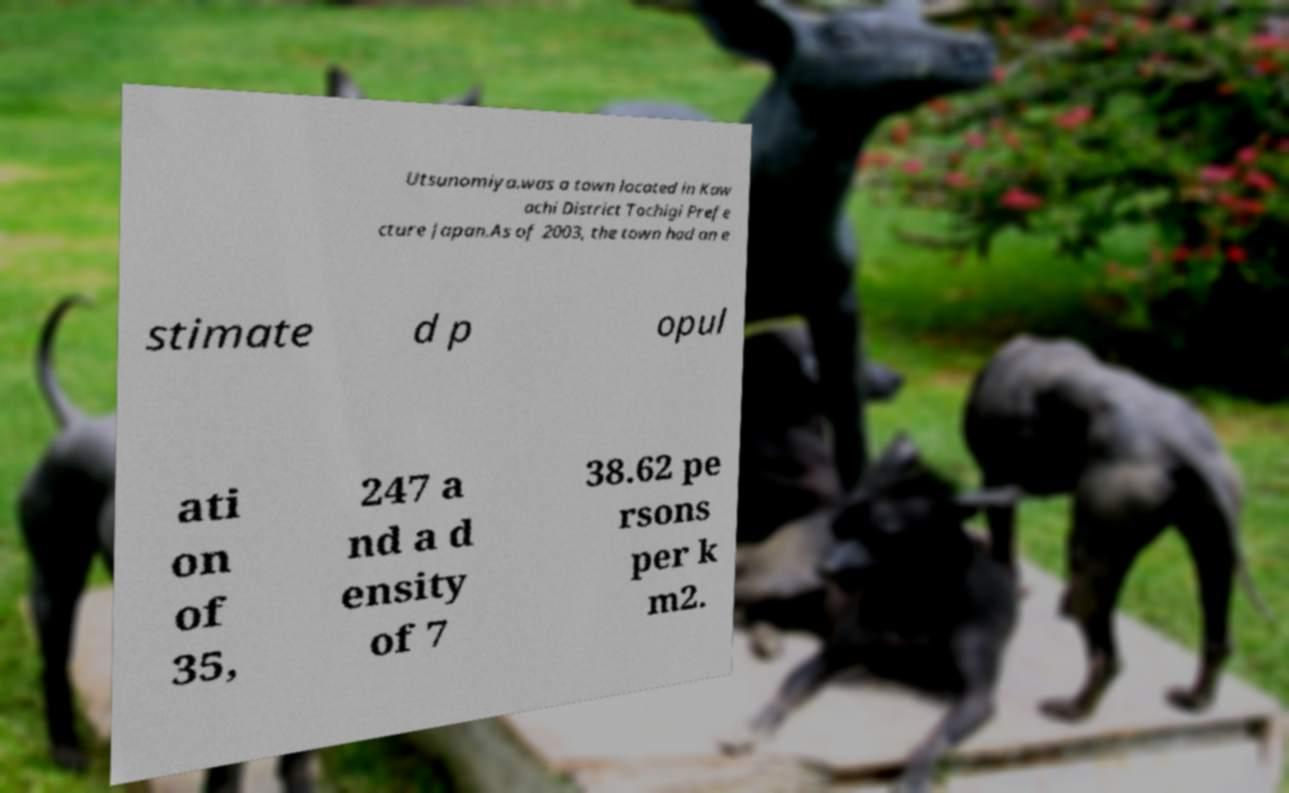I need the written content from this picture converted into text. Can you do that? Utsunomiya.was a town located in Kaw achi District Tochigi Prefe cture Japan.As of 2003, the town had an e stimate d p opul ati on of 35, 247 a nd a d ensity of 7 38.62 pe rsons per k m2. 